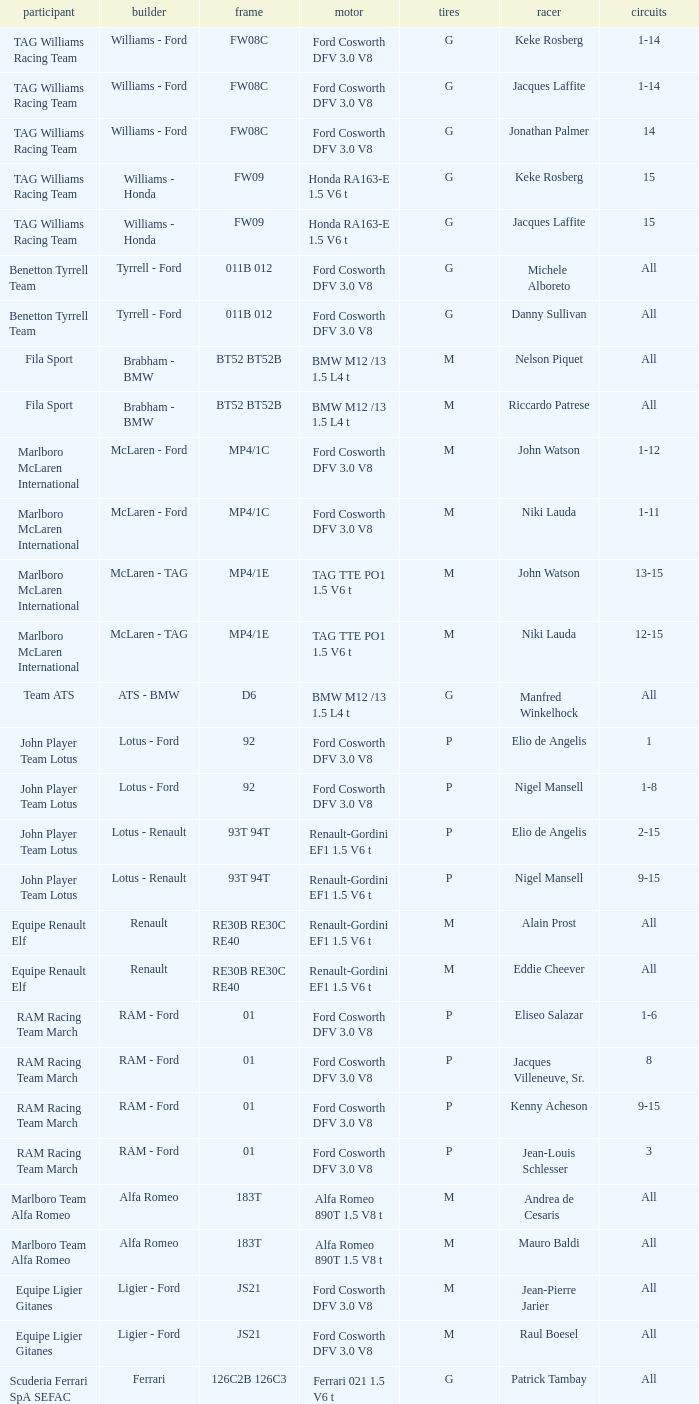Who is the constructor for driver Niki Lauda and a chassis of mp4/1c? McLaren - Ford. 